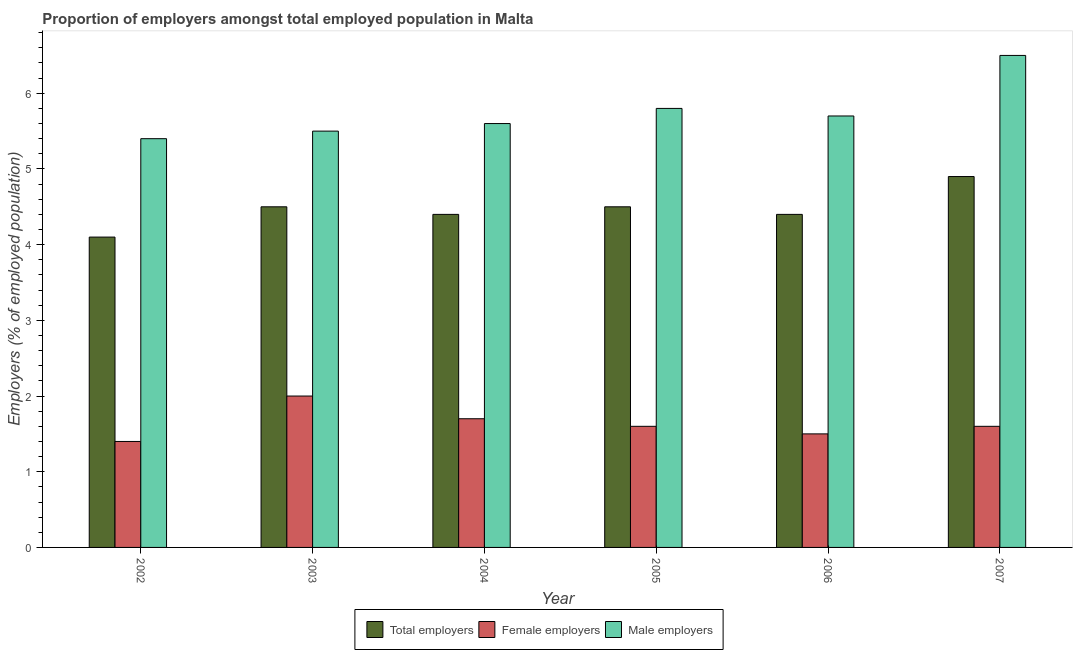How many bars are there on the 2nd tick from the right?
Offer a terse response. 3. What is the percentage of total employers in 2002?
Your answer should be compact. 4.1. Across all years, what is the minimum percentage of total employers?
Keep it short and to the point. 4.1. In which year was the percentage of female employers maximum?
Keep it short and to the point. 2003. In which year was the percentage of female employers minimum?
Offer a very short reply. 2002. What is the total percentage of total employers in the graph?
Ensure brevity in your answer.  26.8. What is the difference between the percentage of total employers in 2002 and that in 2005?
Keep it short and to the point. -0.4. What is the difference between the percentage of female employers in 2003 and the percentage of male employers in 2002?
Offer a terse response. 0.6. What is the average percentage of male employers per year?
Ensure brevity in your answer.  5.75. What is the ratio of the percentage of male employers in 2005 to that in 2006?
Your response must be concise. 1.02. What is the difference between the highest and the second highest percentage of total employers?
Provide a short and direct response. 0.4. What is the difference between the highest and the lowest percentage of male employers?
Provide a succinct answer. 1.1. In how many years, is the percentage of male employers greater than the average percentage of male employers taken over all years?
Make the answer very short. 2. Is the sum of the percentage of male employers in 2003 and 2006 greater than the maximum percentage of female employers across all years?
Give a very brief answer. Yes. What does the 1st bar from the left in 2004 represents?
Ensure brevity in your answer.  Total employers. What does the 3rd bar from the right in 2004 represents?
Keep it short and to the point. Total employers. Are all the bars in the graph horizontal?
Ensure brevity in your answer.  No. How many years are there in the graph?
Keep it short and to the point. 6. Are the values on the major ticks of Y-axis written in scientific E-notation?
Make the answer very short. No. Does the graph contain any zero values?
Offer a very short reply. No. Where does the legend appear in the graph?
Provide a short and direct response. Bottom center. How are the legend labels stacked?
Keep it short and to the point. Horizontal. What is the title of the graph?
Keep it short and to the point. Proportion of employers amongst total employed population in Malta. Does "Transport equipments" appear as one of the legend labels in the graph?
Offer a very short reply. No. What is the label or title of the X-axis?
Your answer should be compact. Year. What is the label or title of the Y-axis?
Make the answer very short. Employers (% of employed population). What is the Employers (% of employed population) of Total employers in 2002?
Your answer should be very brief. 4.1. What is the Employers (% of employed population) in Female employers in 2002?
Make the answer very short. 1.4. What is the Employers (% of employed population) in Male employers in 2002?
Provide a succinct answer. 5.4. What is the Employers (% of employed population) of Male employers in 2003?
Provide a short and direct response. 5.5. What is the Employers (% of employed population) in Total employers in 2004?
Offer a terse response. 4.4. What is the Employers (% of employed population) of Female employers in 2004?
Keep it short and to the point. 1.7. What is the Employers (% of employed population) in Male employers in 2004?
Keep it short and to the point. 5.6. What is the Employers (% of employed population) of Total employers in 2005?
Your response must be concise. 4.5. What is the Employers (% of employed population) in Female employers in 2005?
Provide a succinct answer. 1.6. What is the Employers (% of employed population) of Male employers in 2005?
Ensure brevity in your answer.  5.8. What is the Employers (% of employed population) in Total employers in 2006?
Your answer should be very brief. 4.4. What is the Employers (% of employed population) in Female employers in 2006?
Your response must be concise. 1.5. What is the Employers (% of employed population) of Male employers in 2006?
Your response must be concise. 5.7. What is the Employers (% of employed population) in Total employers in 2007?
Ensure brevity in your answer.  4.9. What is the Employers (% of employed population) in Female employers in 2007?
Provide a short and direct response. 1.6. What is the Employers (% of employed population) in Male employers in 2007?
Provide a short and direct response. 6.5. Across all years, what is the maximum Employers (% of employed population) of Total employers?
Offer a very short reply. 4.9. Across all years, what is the maximum Employers (% of employed population) in Female employers?
Provide a short and direct response. 2. Across all years, what is the maximum Employers (% of employed population) in Male employers?
Keep it short and to the point. 6.5. Across all years, what is the minimum Employers (% of employed population) of Total employers?
Your answer should be compact. 4.1. Across all years, what is the minimum Employers (% of employed population) in Female employers?
Make the answer very short. 1.4. Across all years, what is the minimum Employers (% of employed population) of Male employers?
Offer a very short reply. 5.4. What is the total Employers (% of employed population) of Total employers in the graph?
Offer a terse response. 26.8. What is the total Employers (% of employed population) in Male employers in the graph?
Offer a very short reply. 34.5. What is the difference between the Employers (% of employed population) of Male employers in 2002 and that in 2003?
Your answer should be compact. -0.1. What is the difference between the Employers (% of employed population) in Male employers in 2002 and that in 2004?
Your answer should be very brief. -0.2. What is the difference between the Employers (% of employed population) in Total employers in 2002 and that in 2005?
Your answer should be compact. -0.4. What is the difference between the Employers (% of employed population) in Female employers in 2002 and that in 2005?
Offer a very short reply. -0.2. What is the difference between the Employers (% of employed population) in Male employers in 2002 and that in 2006?
Provide a short and direct response. -0.3. What is the difference between the Employers (% of employed population) of Male employers in 2002 and that in 2007?
Provide a succinct answer. -1.1. What is the difference between the Employers (% of employed population) in Male employers in 2003 and that in 2004?
Provide a succinct answer. -0.1. What is the difference between the Employers (% of employed population) of Female employers in 2003 and that in 2005?
Keep it short and to the point. 0.4. What is the difference between the Employers (% of employed population) in Total employers in 2003 and that in 2006?
Offer a terse response. 0.1. What is the difference between the Employers (% of employed population) of Female employers in 2003 and that in 2006?
Give a very brief answer. 0.5. What is the difference between the Employers (% of employed population) of Male employers in 2003 and that in 2006?
Your response must be concise. -0.2. What is the difference between the Employers (% of employed population) of Female employers in 2003 and that in 2007?
Your response must be concise. 0.4. What is the difference between the Employers (% of employed population) in Male employers in 2003 and that in 2007?
Provide a short and direct response. -1. What is the difference between the Employers (% of employed population) in Female employers in 2004 and that in 2006?
Your answer should be very brief. 0.2. What is the difference between the Employers (% of employed population) of Total employers in 2004 and that in 2007?
Your answer should be compact. -0.5. What is the difference between the Employers (% of employed population) of Female employers in 2004 and that in 2007?
Give a very brief answer. 0.1. What is the difference between the Employers (% of employed population) of Total employers in 2005 and that in 2006?
Give a very brief answer. 0.1. What is the difference between the Employers (% of employed population) in Male employers in 2005 and that in 2006?
Your answer should be compact. 0.1. What is the difference between the Employers (% of employed population) of Female employers in 2005 and that in 2007?
Ensure brevity in your answer.  0. What is the difference between the Employers (% of employed population) of Male employers in 2005 and that in 2007?
Your answer should be very brief. -0.7. What is the difference between the Employers (% of employed population) in Total employers in 2006 and that in 2007?
Your answer should be very brief. -0.5. What is the difference between the Employers (% of employed population) of Female employers in 2006 and that in 2007?
Provide a short and direct response. -0.1. What is the difference between the Employers (% of employed population) of Female employers in 2002 and the Employers (% of employed population) of Male employers in 2004?
Make the answer very short. -4.2. What is the difference between the Employers (% of employed population) of Total employers in 2002 and the Employers (% of employed population) of Female employers in 2005?
Provide a succinct answer. 2.5. What is the difference between the Employers (% of employed population) of Total employers in 2002 and the Employers (% of employed population) of Male employers in 2005?
Give a very brief answer. -1.7. What is the difference between the Employers (% of employed population) in Female employers in 2002 and the Employers (% of employed population) in Male employers in 2005?
Your answer should be compact. -4.4. What is the difference between the Employers (% of employed population) of Total employers in 2002 and the Employers (% of employed population) of Female employers in 2006?
Ensure brevity in your answer.  2.6. What is the difference between the Employers (% of employed population) in Total employers in 2002 and the Employers (% of employed population) in Male employers in 2006?
Offer a very short reply. -1.6. What is the difference between the Employers (% of employed population) of Female employers in 2002 and the Employers (% of employed population) of Male employers in 2006?
Offer a very short reply. -4.3. What is the difference between the Employers (% of employed population) of Total employers in 2003 and the Employers (% of employed population) of Female employers in 2004?
Make the answer very short. 2.8. What is the difference between the Employers (% of employed population) in Total employers in 2003 and the Employers (% of employed population) in Male employers in 2004?
Your answer should be compact. -1.1. What is the difference between the Employers (% of employed population) in Female employers in 2003 and the Employers (% of employed population) in Male employers in 2004?
Your response must be concise. -3.6. What is the difference between the Employers (% of employed population) of Female employers in 2003 and the Employers (% of employed population) of Male employers in 2005?
Provide a short and direct response. -3.8. What is the difference between the Employers (% of employed population) of Female employers in 2003 and the Employers (% of employed population) of Male employers in 2006?
Give a very brief answer. -3.7. What is the difference between the Employers (% of employed population) in Female employers in 2003 and the Employers (% of employed population) in Male employers in 2007?
Your answer should be very brief. -4.5. What is the difference between the Employers (% of employed population) of Total employers in 2004 and the Employers (% of employed population) of Female employers in 2005?
Keep it short and to the point. 2.8. What is the difference between the Employers (% of employed population) in Total employers in 2004 and the Employers (% of employed population) in Male employers in 2005?
Provide a succinct answer. -1.4. What is the difference between the Employers (% of employed population) of Female employers in 2004 and the Employers (% of employed population) of Male employers in 2005?
Give a very brief answer. -4.1. What is the difference between the Employers (% of employed population) in Total employers in 2004 and the Employers (% of employed population) in Male employers in 2007?
Make the answer very short. -2.1. What is the difference between the Employers (% of employed population) of Female employers in 2004 and the Employers (% of employed population) of Male employers in 2007?
Your answer should be compact. -4.8. What is the difference between the Employers (% of employed population) of Total employers in 2005 and the Employers (% of employed population) of Female employers in 2006?
Offer a terse response. 3. What is the difference between the Employers (% of employed population) of Female employers in 2005 and the Employers (% of employed population) of Male employers in 2007?
Give a very brief answer. -4.9. What is the difference between the Employers (% of employed population) of Total employers in 2006 and the Employers (% of employed population) of Female employers in 2007?
Keep it short and to the point. 2.8. What is the difference between the Employers (% of employed population) in Female employers in 2006 and the Employers (% of employed population) in Male employers in 2007?
Offer a terse response. -5. What is the average Employers (% of employed population) of Total employers per year?
Keep it short and to the point. 4.47. What is the average Employers (% of employed population) of Female employers per year?
Give a very brief answer. 1.63. What is the average Employers (% of employed population) of Male employers per year?
Your answer should be compact. 5.75. In the year 2002, what is the difference between the Employers (% of employed population) of Total employers and Employers (% of employed population) of Female employers?
Offer a very short reply. 2.7. In the year 2003, what is the difference between the Employers (% of employed population) in Total employers and Employers (% of employed population) in Female employers?
Offer a very short reply. 2.5. In the year 2003, what is the difference between the Employers (% of employed population) in Total employers and Employers (% of employed population) in Male employers?
Your answer should be very brief. -1. In the year 2005, what is the difference between the Employers (% of employed population) of Total employers and Employers (% of employed population) of Female employers?
Your answer should be very brief. 2.9. In the year 2006, what is the difference between the Employers (% of employed population) in Total employers and Employers (% of employed population) in Male employers?
Offer a terse response. -1.3. In the year 2007, what is the difference between the Employers (% of employed population) in Total employers and Employers (% of employed population) in Male employers?
Your answer should be compact. -1.6. In the year 2007, what is the difference between the Employers (% of employed population) of Female employers and Employers (% of employed population) of Male employers?
Keep it short and to the point. -4.9. What is the ratio of the Employers (% of employed population) in Total employers in 2002 to that in 2003?
Offer a very short reply. 0.91. What is the ratio of the Employers (% of employed population) in Female employers in 2002 to that in 2003?
Give a very brief answer. 0.7. What is the ratio of the Employers (% of employed population) in Male employers in 2002 to that in 2003?
Give a very brief answer. 0.98. What is the ratio of the Employers (% of employed population) in Total employers in 2002 to that in 2004?
Make the answer very short. 0.93. What is the ratio of the Employers (% of employed population) of Female employers in 2002 to that in 2004?
Offer a very short reply. 0.82. What is the ratio of the Employers (% of employed population) of Total employers in 2002 to that in 2005?
Offer a very short reply. 0.91. What is the ratio of the Employers (% of employed population) of Female employers in 2002 to that in 2005?
Your answer should be compact. 0.88. What is the ratio of the Employers (% of employed population) of Total employers in 2002 to that in 2006?
Offer a very short reply. 0.93. What is the ratio of the Employers (% of employed population) in Female employers in 2002 to that in 2006?
Provide a succinct answer. 0.93. What is the ratio of the Employers (% of employed population) of Male employers in 2002 to that in 2006?
Ensure brevity in your answer.  0.95. What is the ratio of the Employers (% of employed population) of Total employers in 2002 to that in 2007?
Provide a succinct answer. 0.84. What is the ratio of the Employers (% of employed population) in Female employers in 2002 to that in 2007?
Provide a succinct answer. 0.88. What is the ratio of the Employers (% of employed population) of Male employers in 2002 to that in 2007?
Give a very brief answer. 0.83. What is the ratio of the Employers (% of employed population) of Total employers in 2003 to that in 2004?
Give a very brief answer. 1.02. What is the ratio of the Employers (% of employed population) in Female employers in 2003 to that in 2004?
Give a very brief answer. 1.18. What is the ratio of the Employers (% of employed population) of Male employers in 2003 to that in 2004?
Provide a short and direct response. 0.98. What is the ratio of the Employers (% of employed population) of Female employers in 2003 to that in 2005?
Make the answer very short. 1.25. What is the ratio of the Employers (% of employed population) in Male employers in 2003 to that in 2005?
Your answer should be very brief. 0.95. What is the ratio of the Employers (% of employed population) in Total employers in 2003 to that in 2006?
Ensure brevity in your answer.  1.02. What is the ratio of the Employers (% of employed population) in Female employers in 2003 to that in 2006?
Offer a very short reply. 1.33. What is the ratio of the Employers (% of employed population) of Male employers in 2003 to that in 2006?
Provide a succinct answer. 0.96. What is the ratio of the Employers (% of employed population) of Total employers in 2003 to that in 2007?
Provide a succinct answer. 0.92. What is the ratio of the Employers (% of employed population) of Male employers in 2003 to that in 2007?
Your answer should be very brief. 0.85. What is the ratio of the Employers (% of employed population) in Total employers in 2004 to that in 2005?
Your response must be concise. 0.98. What is the ratio of the Employers (% of employed population) in Male employers in 2004 to that in 2005?
Provide a succinct answer. 0.97. What is the ratio of the Employers (% of employed population) in Total employers in 2004 to that in 2006?
Your answer should be very brief. 1. What is the ratio of the Employers (% of employed population) in Female employers in 2004 to that in 2006?
Offer a terse response. 1.13. What is the ratio of the Employers (% of employed population) in Male employers in 2004 to that in 2006?
Make the answer very short. 0.98. What is the ratio of the Employers (% of employed population) in Total employers in 2004 to that in 2007?
Make the answer very short. 0.9. What is the ratio of the Employers (% of employed population) in Male employers in 2004 to that in 2007?
Give a very brief answer. 0.86. What is the ratio of the Employers (% of employed population) in Total employers in 2005 to that in 2006?
Your answer should be compact. 1.02. What is the ratio of the Employers (% of employed population) in Female employers in 2005 to that in 2006?
Give a very brief answer. 1.07. What is the ratio of the Employers (% of employed population) of Male employers in 2005 to that in 2006?
Keep it short and to the point. 1.02. What is the ratio of the Employers (% of employed population) of Total employers in 2005 to that in 2007?
Ensure brevity in your answer.  0.92. What is the ratio of the Employers (% of employed population) of Male employers in 2005 to that in 2007?
Give a very brief answer. 0.89. What is the ratio of the Employers (% of employed population) in Total employers in 2006 to that in 2007?
Your answer should be compact. 0.9. What is the ratio of the Employers (% of employed population) in Female employers in 2006 to that in 2007?
Your answer should be very brief. 0.94. What is the ratio of the Employers (% of employed population) in Male employers in 2006 to that in 2007?
Offer a very short reply. 0.88. What is the difference between the highest and the second highest Employers (% of employed population) of Total employers?
Give a very brief answer. 0.4. What is the difference between the highest and the second highest Employers (% of employed population) of Female employers?
Give a very brief answer. 0.3. What is the difference between the highest and the lowest Employers (% of employed population) in Total employers?
Offer a very short reply. 0.8. What is the difference between the highest and the lowest Employers (% of employed population) of Male employers?
Provide a succinct answer. 1.1. 